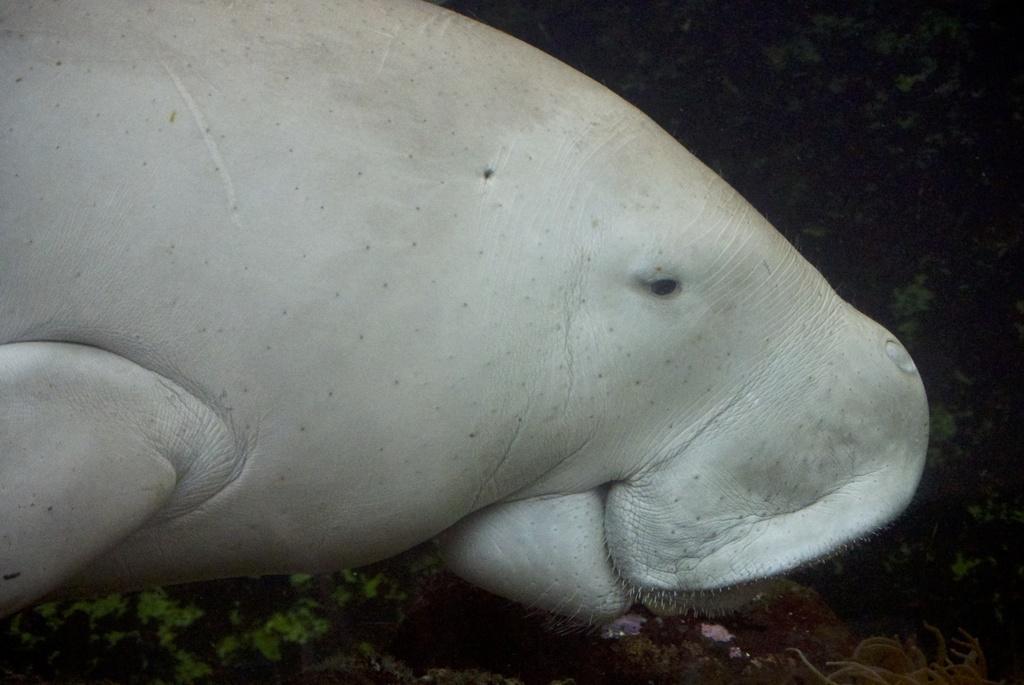In one or two sentences, can you explain what this image depicts? In the foreground of this image, there is an aquatic animal under the water. 